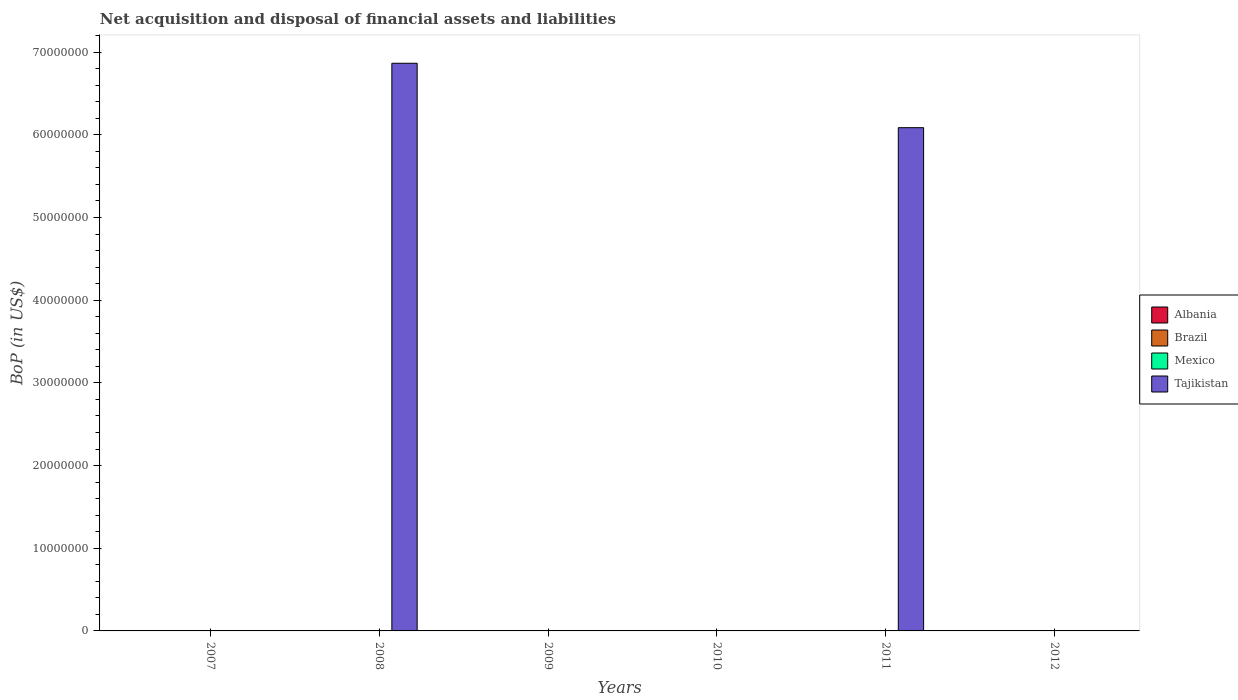How many different coloured bars are there?
Offer a very short reply. 1. Are the number of bars per tick equal to the number of legend labels?
Keep it short and to the point. No. Are the number of bars on each tick of the X-axis equal?
Give a very brief answer. No. How many bars are there on the 5th tick from the left?
Provide a succinct answer. 1. What is the label of the 1st group of bars from the left?
Ensure brevity in your answer.  2007. In how many cases, is the number of bars for a given year not equal to the number of legend labels?
Your answer should be compact. 6. Across all years, what is the minimum Balance of Payments in Brazil?
Offer a very short reply. 0. What is the total Balance of Payments in Tajikistan in the graph?
Keep it short and to the point. 1.30e+08. What is the average Balance of Payments in Albania per year?
Your answer should be very brief. 0. What is the difference between the highest and the lowest Balance of Payments in Tajikistan?
Your response must be concise. 6.87e+07. In how many years, is the Balance of Payments in Brazil greater than the average Balance of Payments in Brazil taken over all years?
Keep it short and to the point. 0. How many years are there in the graph?
Provide a succinct answer. 6. Does the graph contain any zero values?
Give a very brief answer. Yes. How are the legend labels stacked?
Make the answer very short. Vertical. What is the title of the graph?
Provide a succinct answer. Net acquisition and disposal of financial assets and liabilities. Does "Tunisia" appear as one of the legend labels in the graph?
Provide a short and direct response. No. What is the label or title of the X-axis?
Provide a succinct answer. Years. What is the label or title of the Y-axis?
Give a very brief answer. BoP (in US$). What is the BoP (in US$) in Tajikistan in 2008?
Your answer should be compact. 6.87e+07. What is the BoP (in US$) in Brazil in 2009?
Keep it short and to the point. 0. What is the BoP (in US$) of Tajikistan in 2009?
Provide a succinct answer. 0. What is the BoP (in US$) of Albania in 2010?
Ensure brevity in your answer.  0. What is the BoP (in US$) in Brazil in 2010?
Offer a very short reply. 0. What is the BoP (in US$) in Mexico in 2010?
Ensure brevity in your answer.  0. What is the BoP (in US$) of Albania in 2011?
Your answer should be very brief. 0. What is the BoP (in US$) in Brazil in 2011?
Your answer should be compact. 0. What is the BoP (in US$) of Mexico in 2011?
Your answer should be very brief. 0. What is the BoP (in US$) of Tajikistan in 2011?
Your answer should be compact. 6.09e+07. Across all years, what is the maximum BoP (in US$) in Tajikistan?
Give a very brief answer. 6.87e+07. Across all years, what is the minimum BoP (in US$) in Tajikistan?
Ensure brevity in your answer.  0. What is the total BoP (in US$) of Albania in the graph?
Your answer should be very brief. 0. What is the total BoP (in US$) of Mexico in the graph?
Offer a very short reply. 0. What is the total BoP (in US$) of Tajikistan in the graph?
Ensure brevity in your answer.  1.30e+08. What is the difference between the BoP (in US$) in Tajikistan in 2008 and that in 2011?
Provide a succinct answer. 7.79e+06. What is the average BoP (in US$) in Brazil per year?
Your response must be concise. 0. What is the average BoP (in US$) in Mexico per year?
Your answer should be compact. 0. What is the average BoP (in US$) of Tajikistan per year?
Make the answer very short. 2.16e+07. What is the ratio of the BoP (in US$) in Tajikistan in 2008 to that in 2011?
Provide a succinct answer. 1.13. What is the difference between the highest and the lowest BoP (in US$) of Tajikistan?
Your response must be concise. 6.87e+07. 